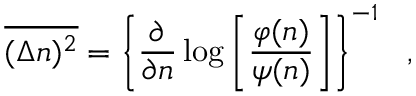Convert formula to latex. <formula><loc_0><loc_0><loc_500><loc_500>\overline { { { ( \Delta n ) ^ { 2 } } } } = \left \{ \frac { \partial } { \partial n } \log \left [ \frac { \varphi ( n ) } { \psi ( n ) } \right ] \right \} ^ { - 1 } \ \ ,</formula> 